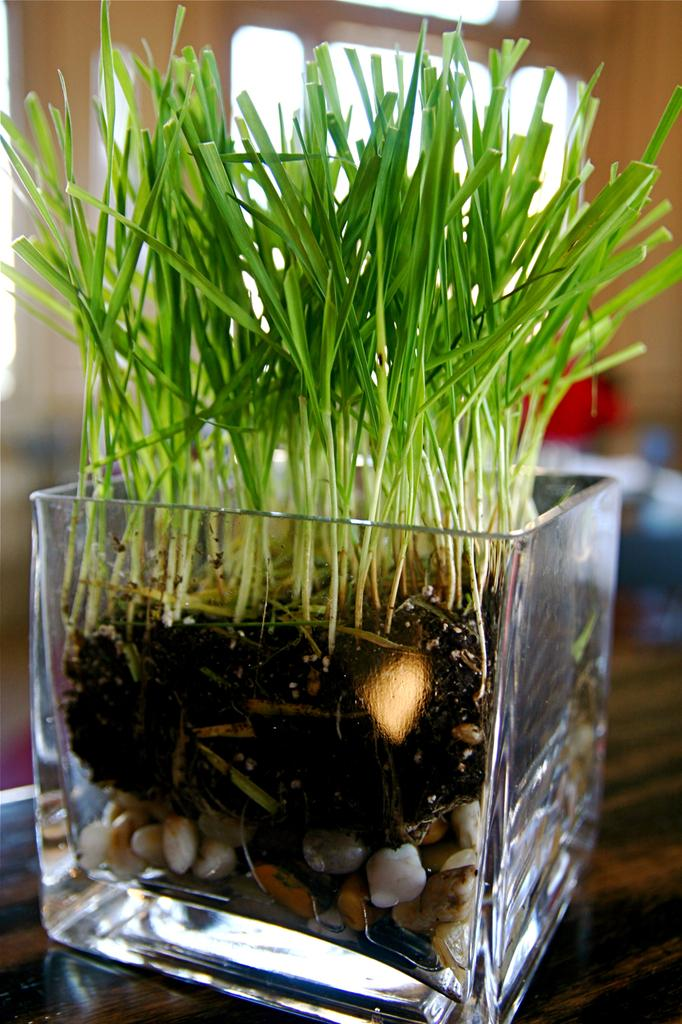What can be observed about the background of the image? The background of the picture is blurred. What type of container is present in the image? There is a square glass pot in the image. Where is the pot placed? The pot is placed on a wooden platform. What is inside the pot? There is a plant and pebbles in the pot. What is the manager doing in the image? There is no manager present in the image. What point is being made by the plant in the pot? The plant in the pot is not making any point; it is simply a living organism in the image. 